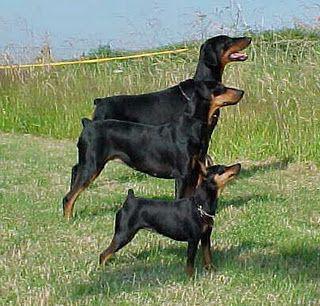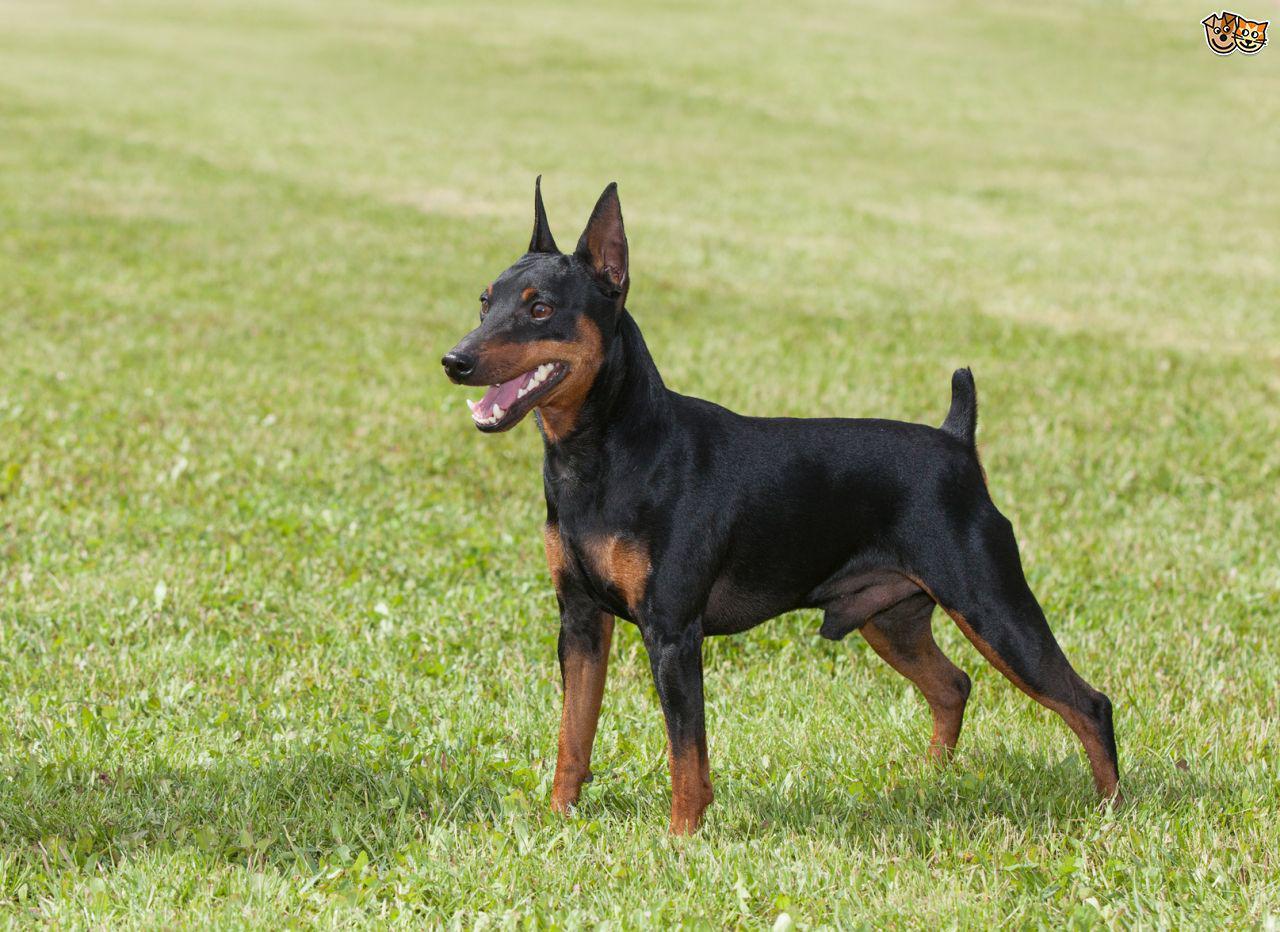The first image is the image on the left, the second image is the image on the right. For the images displayed, is the sentence "tere is a dog sitting in the grass wearing a color and has pointy ears" factually correct? Answer yes or no. No. The first image is the image on the left, the second image is the image on the right. Evaluate the accuracy of this statement regarding the images: "The left image contains at least two dogs.". Is it true? Answer yes or no. Yes. 